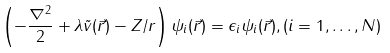<formula> <loc_0><loc_0><loc_500><loc_500>\left ( - \frac { \nabla ^ { 2 } } { 2 } + \lambda \tilde { v } ( \vec { r } ) - Z / r \right ) \psi _ { i } ( \vec { r } ) = \epsilon _ { i } \psi _ { i } ( \vec { r } ) , ( i = 1 , \dots , N )</formula> 